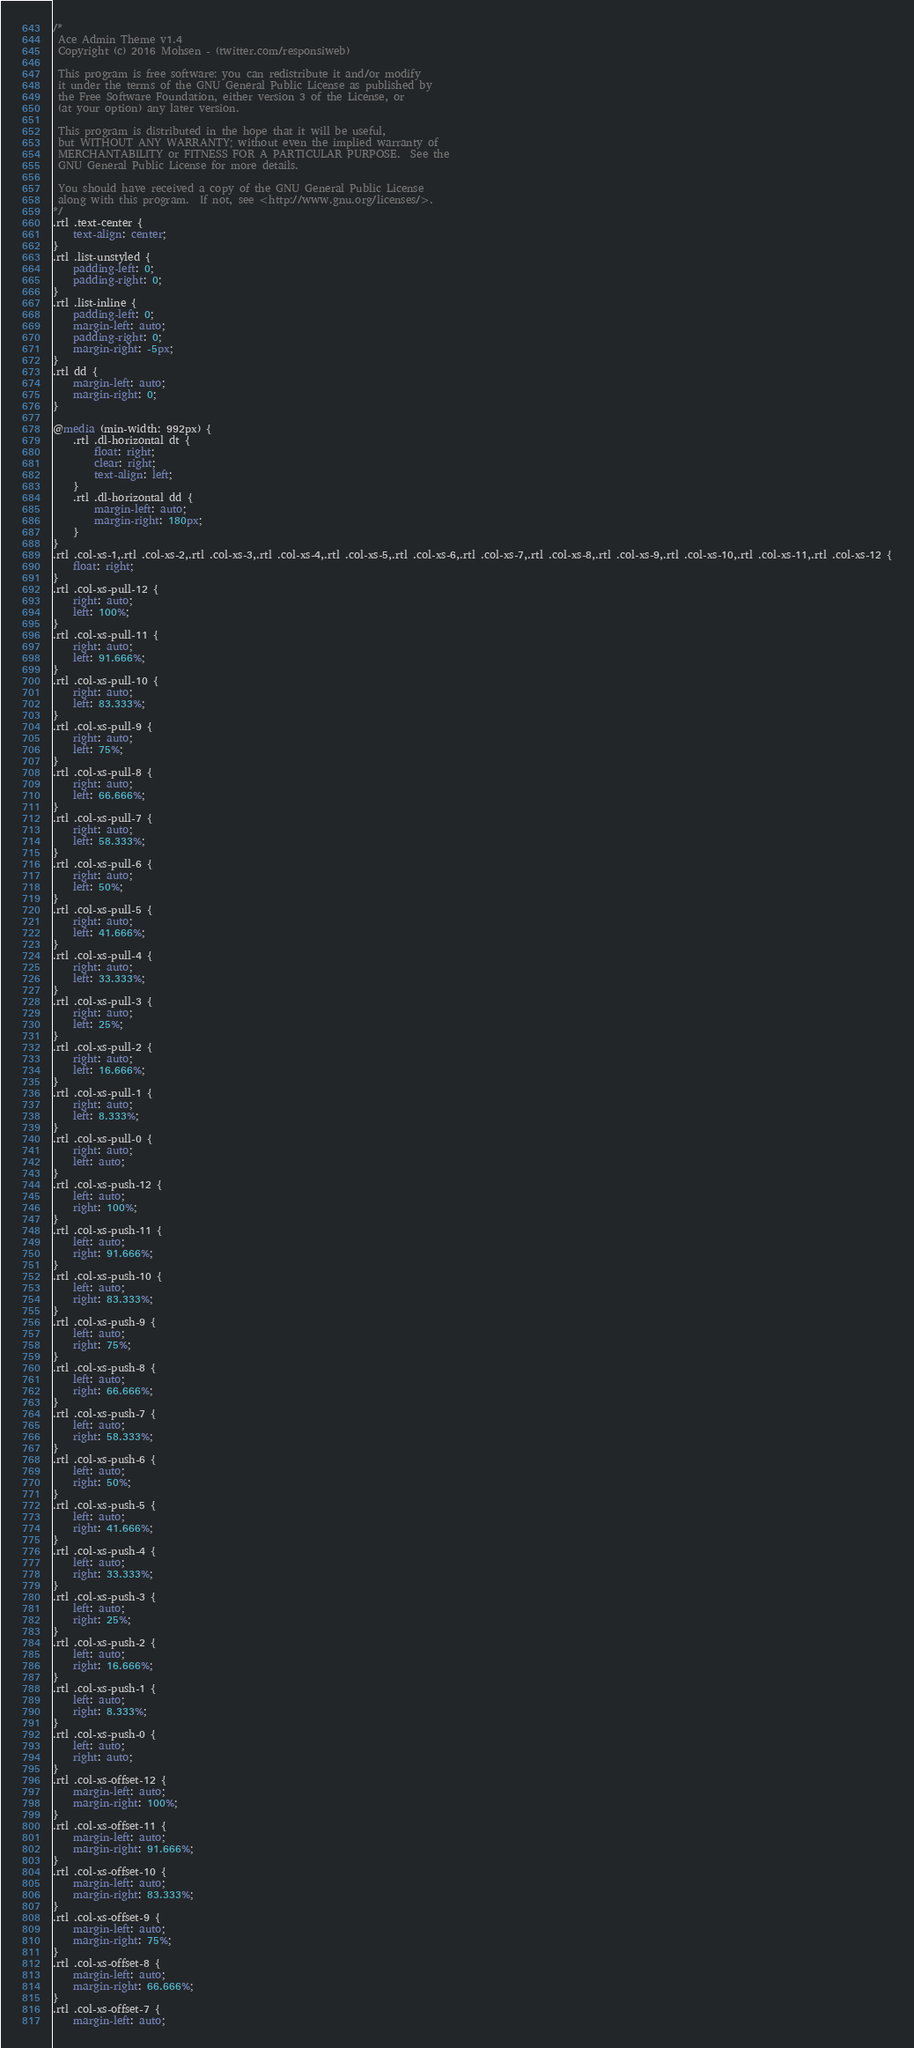<code> <loc_0><loc_0><loc_500><loc_500><_CSS_>/*
 Ace Admin Theme v1.4
 Copyright (c) 2016 Mohsen - (twitter.com/responsiweb)

 This program is free software: you can redistribute it and/or modify
 it under the terms of the GNU General Public License as published by
 the Free Software Foundation, either version 3 of the License, or
 (at your option) any later version.

 This program is distributed in the hope that it will be useful,
 but WITHOUT ANY WARRANTY; without even the implied warranty of
 MERCHANTABILITY or FITNESS FOR A PARTICULAR PURPOSE.  See the
 GNU General Public License for more details.

 You should have received a copy of the GNU General Public License
 along with this program.  If not, see <http://www.gnu.org/licenses/>.
*/
.rtl .text-center {
    text-align: center;
}
.rtl .list-unstyled {
    padding-left: 0;
    padding-right: 0;
}
.rtl .list-inline {
    padding-left: 0;
    margin-left: auto;
    padding-right: 0;
    margin-right: -5px;
}
.rtl dd {
    margin-left: auto;
    margin-right: 0;
}

@media (min-width: 992px) {
    .rtl .dl-horizontal dt {
        float: right;
        clear: right;
        text-align: left;
    }
    .rtl .dl-horizontal dd {
        margin-left: auto;
        margin-right: 180px;
    }
}
.rtl .col-xs-1,.rtl .col-xs-2,.rtl .col-xs-3,.rtl .col-xs-4,.rtl .col-xs-5,.rtl .col-xs-6,.rtl .col-xs-7,.rtl .col-xs-8,.rtl .col-xs-9,.rtl .col-xs-10,.rtl .col-xs-11,.rtl .col-xs-12 {
    float: right;
}
.rtl .col-xs-pull-12 {
    right: auto;
    left: 100%;
}
.rtl .col-xs-pull-11 {
    right: auto;
    left: 91.666%;
}
.rtl .col-xs-pull-10 {
    right: auto;
    left: 83.333%;
}
.rtl .col-xs-pull-9 {
    right: auto;
    left: 75%;
}
.rtl .col-xs-pull-8 {
    right: auto;
    left: 66.666%;
}
.rtl .col-xs-pull-7 {
    right: auto;
    left: 58.333%;
}
.rtl .col-xs-pull-6 {
    right: auto;
    left: 50%;
}
.rtl .col-xs-pull-5 {
    right: auto;
    left: 41.666%;
}
.rtl .col-xs-pull-4 {
    right: auto;
    left: 33.333%;
}
.rtl .col-xs-pull-3 {
    right: auto;
    left: 25%;
}
.rtl .col-xs-pull-2 {
    right: auto;
    left: 16.666%;
}
.rtl .col-xs-pull-1 {
    right: auto;
    left: 8.333%;
}
.rtl .col-xs-pull-0 {
    right: auto;
    left: auto;
}
.rtl .col-xs-push-12 {
    left: auto;
    right: 100%;
}
.rtl .col-xs-push-11 {
    left: auto;
    right: 91.666%;
}
.rtl .col-xs-push-10 {
    left: auto;
    right: 83.333%;
}
.rtl .col-xs-push-9 {
    left: auto;
    right: 75%;
}
.rtl .col-xs-push-8 {
    left: auto;
    right: 66.666%;
}
.rtl .col-xs-push-7 {
    left: auto;
    right: 58.333%;
}
.rtl .col-xs-push-6 {
    left: auto;
    right: 50%;
}
.rtl .col-xs-push-5 {
    left: auto;
    right: 41.666%;
}
.rtl .col-xs-push-4 {
    left: auto;
    right: 33.333%;
}
.rtl .col-xs-push-3 {
    left: auto;
    right: 25%;
}
.rtl .col-xs-push-2 {
    left: auto;
    right: 16.666%;
}
.rtl .col-xs-push-1 {
    left: auto;
    right: 8.333%;
}
.rtl .col-xs-push-0 {
    left: auto;
    right: auto;
}
.rtl .col-xs-offset-12 {
    margin-left: auto;
    margin-right: 100%;
}
.rtl .col-xs-offset-11 {
    margin-left: auto;
    margin-right: 91.666%;
}
.rtl .col-xs-offset-10 {
    margin-left: auto;
    margin-right: 83.333%;
}
.rtl .col-xs-offset-9 {
    margin-left: auto;
    margin-right: 75%;
}
.rtl .col-xs-offset-8 {
    margin-left: auto;
    margin-right: 66.666%;
}
.rtl .col-xs-offset-7 {
    margin-left: auto;</code> 